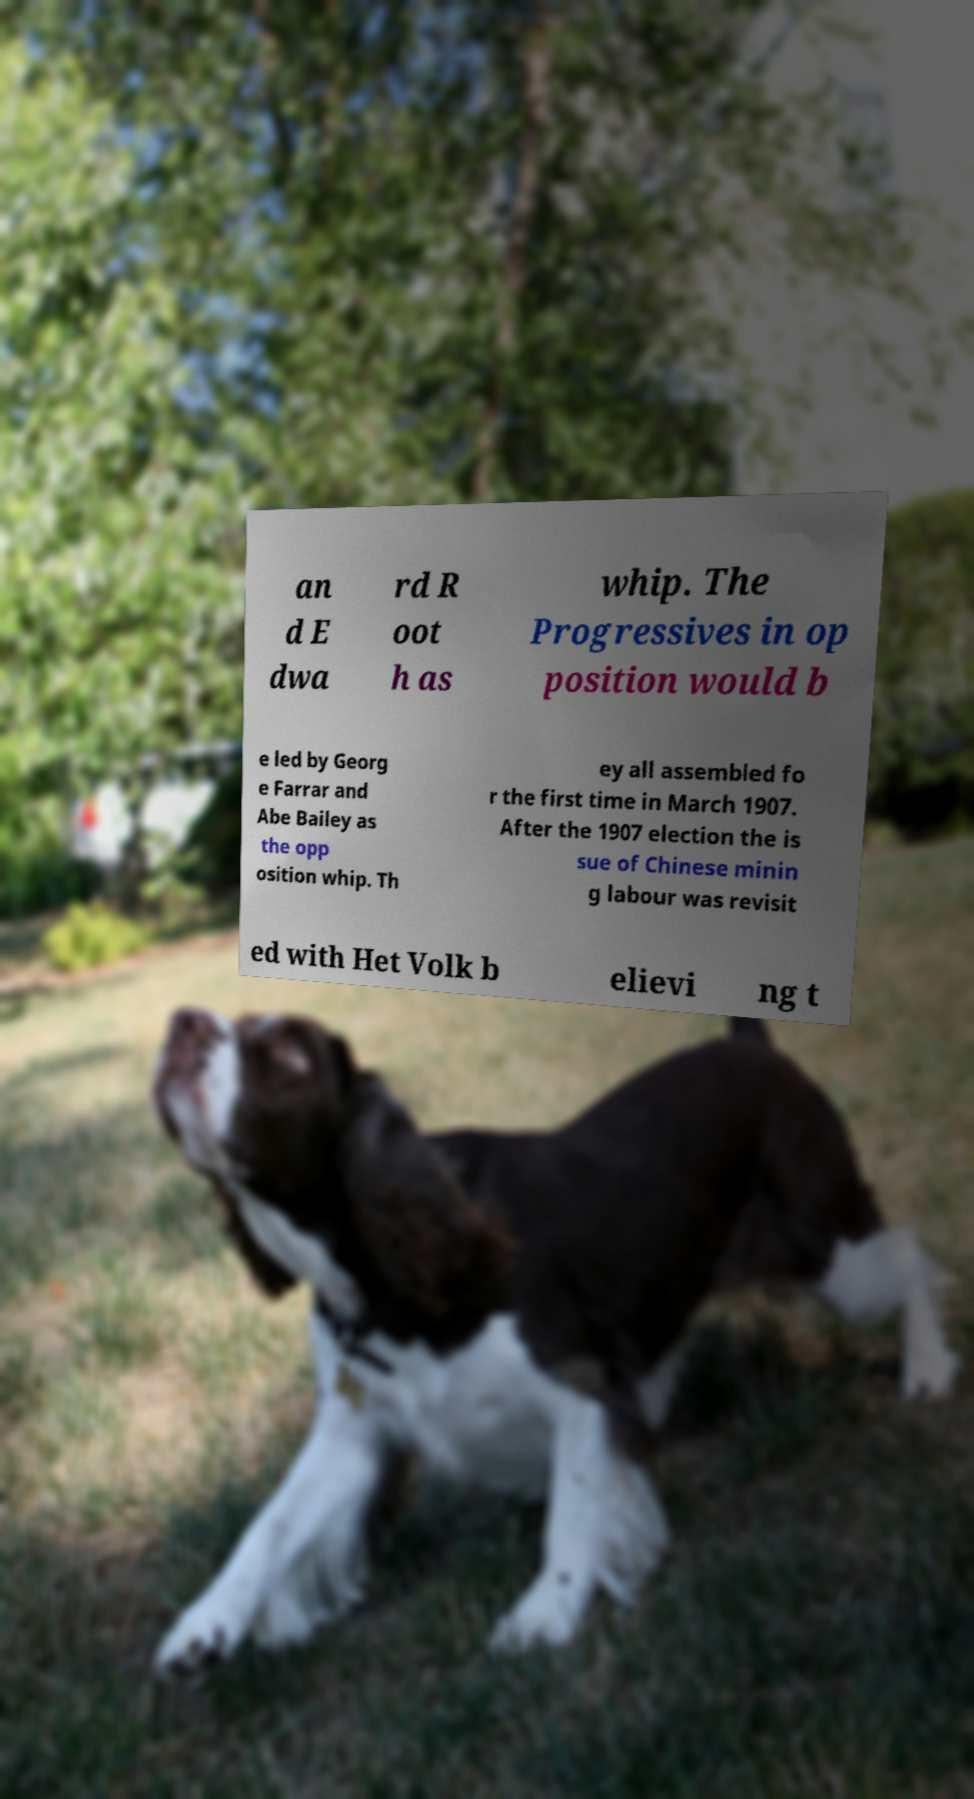Please identify and transcribe the text found in this image. an d E dwa rd R oot h as whip. The Progressives in op position would b e led by Georg e Farrar and Abe Bailey as the opp osition whip. Th ey all assembled fo r the first time in March 1907. After the 1907 election the is sue of Chinese minin g labour was revisit ed with Het Volk b elievi ng t 